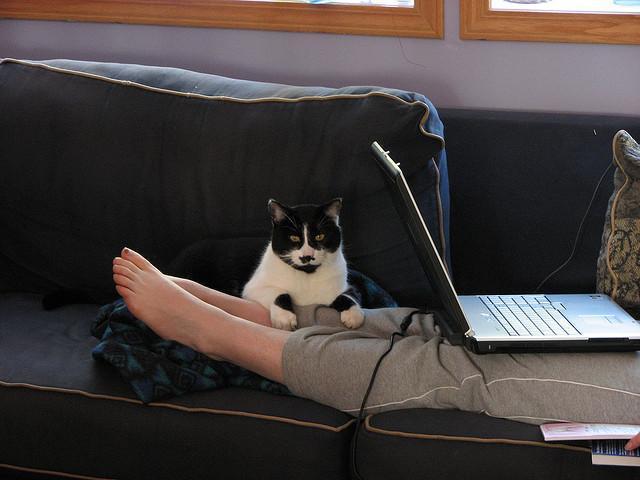How many cats are there?
Give a very brief answer. 1. How many cars in the shot?
Give a very brief answer. 0. 